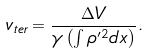Convert formula to latex. <formula><loc_0><loc_0><loc_500><loc_500>v _ { t e r } = \frac { \Delta V } { \gamma \left ( \int \rho ^ { \prime 2 } d x \right ) } .</formula> 